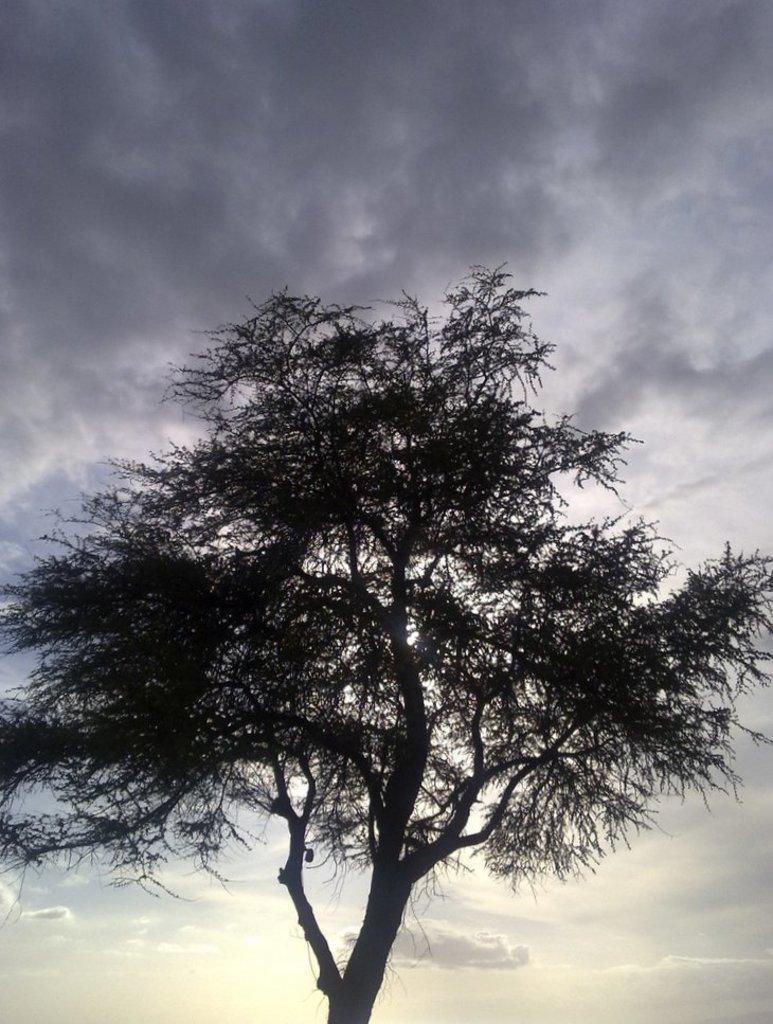Could you give a brief overview of what you see in this image? In the foreground of the picture there is a tree. In the background it is sky, sky is cloudy. 